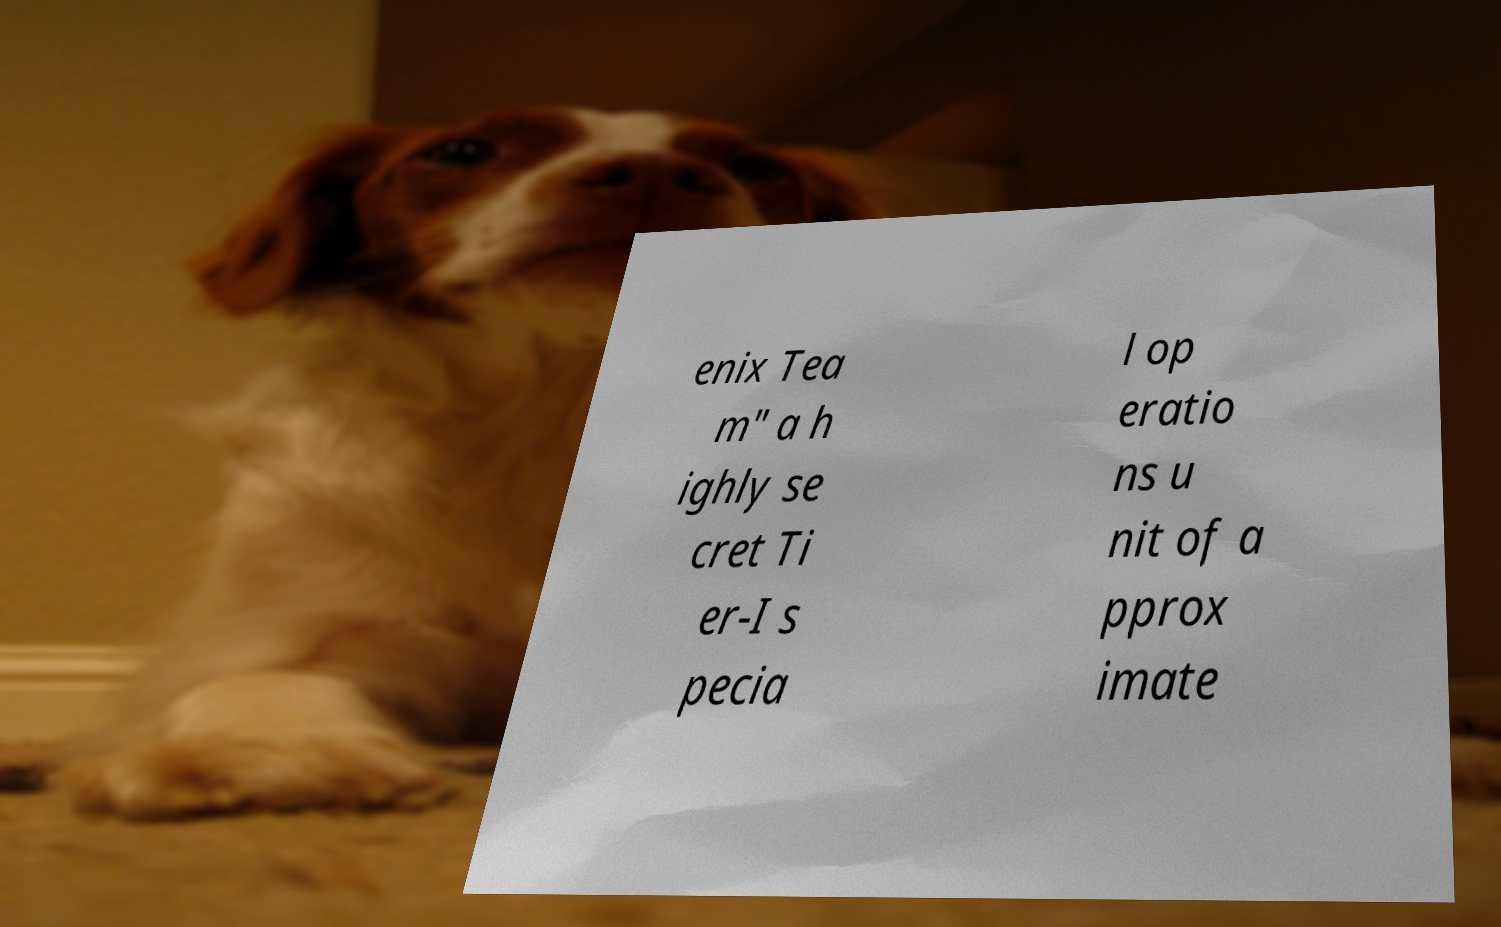Can you read and provide the text displayed in the image?This photo seems to have some interesting text. Can you extract and type it out for me? enix Tea m" a h ighly se cret Ti er-I s pecia l op eratio ns u nit of a pprox imate 